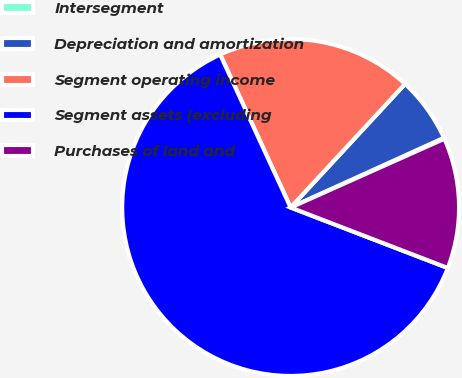<chart> <loc_0><loc_0><loc_500><loc_500><pie_chart><fcel>Intersegment<fcel>Depreciation and amortization<fcel>Segment operating income<fcel>Segment assets (excluding<fcel>Purchases of land and<nl><fcel>0.1%<fcel>6.32%<fcel>18.76%<fcel>62.29%<fcel>12.54%<nl></chart> 